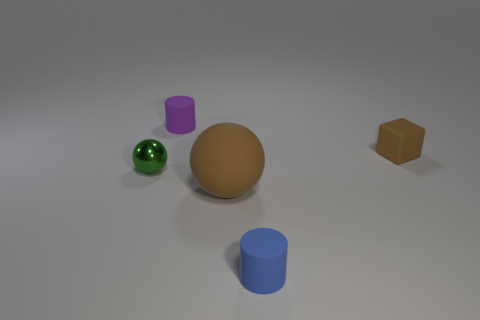Add 1 small blocks. How many objects exist? 6 Subtract all cylinders. How many objects are left? 3 Add 1 blue cylinders. How many blue cylinders exist? 2 Subtract 0 blue spheres. How many objects are left? 5 Subtract all spheres. Subtract all large brown matte spheres. How many objects are left? 2 Add 1 big brown objects. How many big brown objects are left? 2 